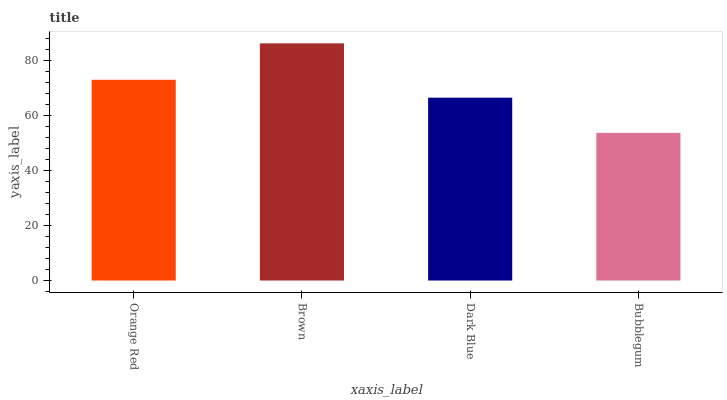Is Bubblegum the minimum?
Answer yes or no. Yes. Is Brown the maximum?
Answer yes or no. Yes. Is Dark Blue the minimum?
Answer yes or no. No. Is Dark Blue the maximum?
Answer yes or no. No. Is Brown greater than Dark Blue?
Answer yes or no. Yes. Is Dark Blue less than Brown?
Answer yes or no. Yes. Is Dark Blue greater than Brown?
Answer yes or no. No. Is Brown less than Dark Blue?
Answer yes or no. No. Is Orange Red the high median?
Answer yes or no. Yes. Is Dark Blue the low median?
Answer yes or no. Yes. Is Brown the high median?
Answer yes or no. No. Is Brown the low median?
Answer yes or no. No. 